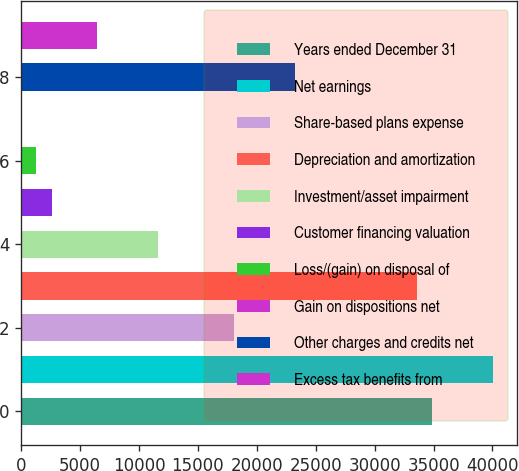Convert chart to OTSL. <chart><loc_0><loc_0><loc_500><loc_500><bar_chart><fcel>Years ended December 31<fcel>Net earnings<fcel>Share-based plans expense<fcel>Depreciation and amortization<fcel>Investment/asset impairment<fcel>Customer financing valuation<fcel>Loss/(gain) on disposal of<fcel>Gain on dispositions net<fcel>Other charges and credits net<fcel>Excess tax benefits from<nl><fcel>34879.9<fcel>40046.7<fcel>18087.8<fcel>33588.2<fcel>11629.3<fcel>2587.4<fcel>1295.7<fcel>4<fcel>23254.6<fcel>6462.5<nl></chart> 